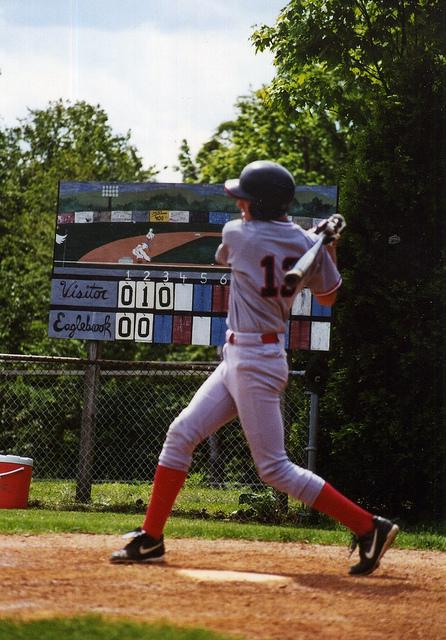Which team is winning?

Choices:
A) mets
B) visitor
C) eaglebrook
D) jets visitor 